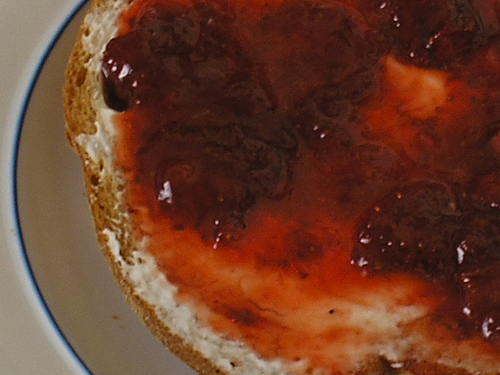<image>
Is there a jelly above the cream cheese? No. The jelly is not positioned above the cream cheese. The vertical arrangement shows a different relationship. 